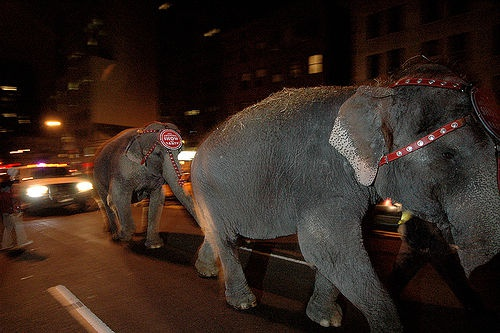Describe the objects in this image and their specific colors. I can see elephant in black, gray, and maroon tones, elephant in black, maroon, and gray tones, people in black, maroon, and olive tones, car in black, maroon, and ivory tones, and people in black, maroon, and gray tones in this image. 